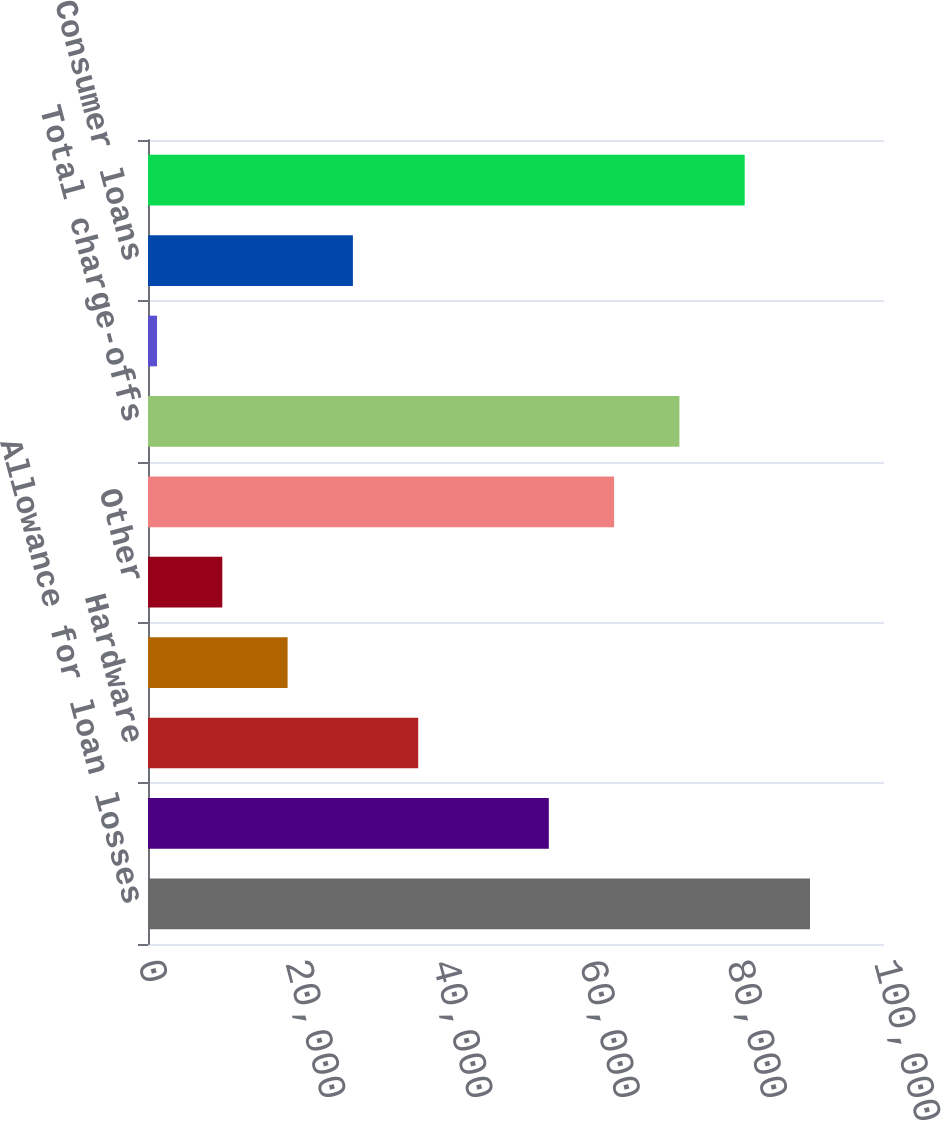Convert chart. <chart><loc_0><loc_0><loc_500><loc_500><bar_chart><fcel>Allowance for loan losses<fcel>Software and internet<fcel>Hardware<fcel>Life science/healthcare<fcel>Other<fcel>Total commercial loans<fcel>Total charge-offs<fcel>Premium wine<fcel>Consumer loans<fcel>Total recoveries<nl><fcel>89947<fcel>54457.4<fcel>36712.6<fcel>18967.8<fcel>10095.4<fcel>63329.8<fcel>72202.2<fcel>1223<fcel>27840.2<fcel>81074.6<nl></chart> 